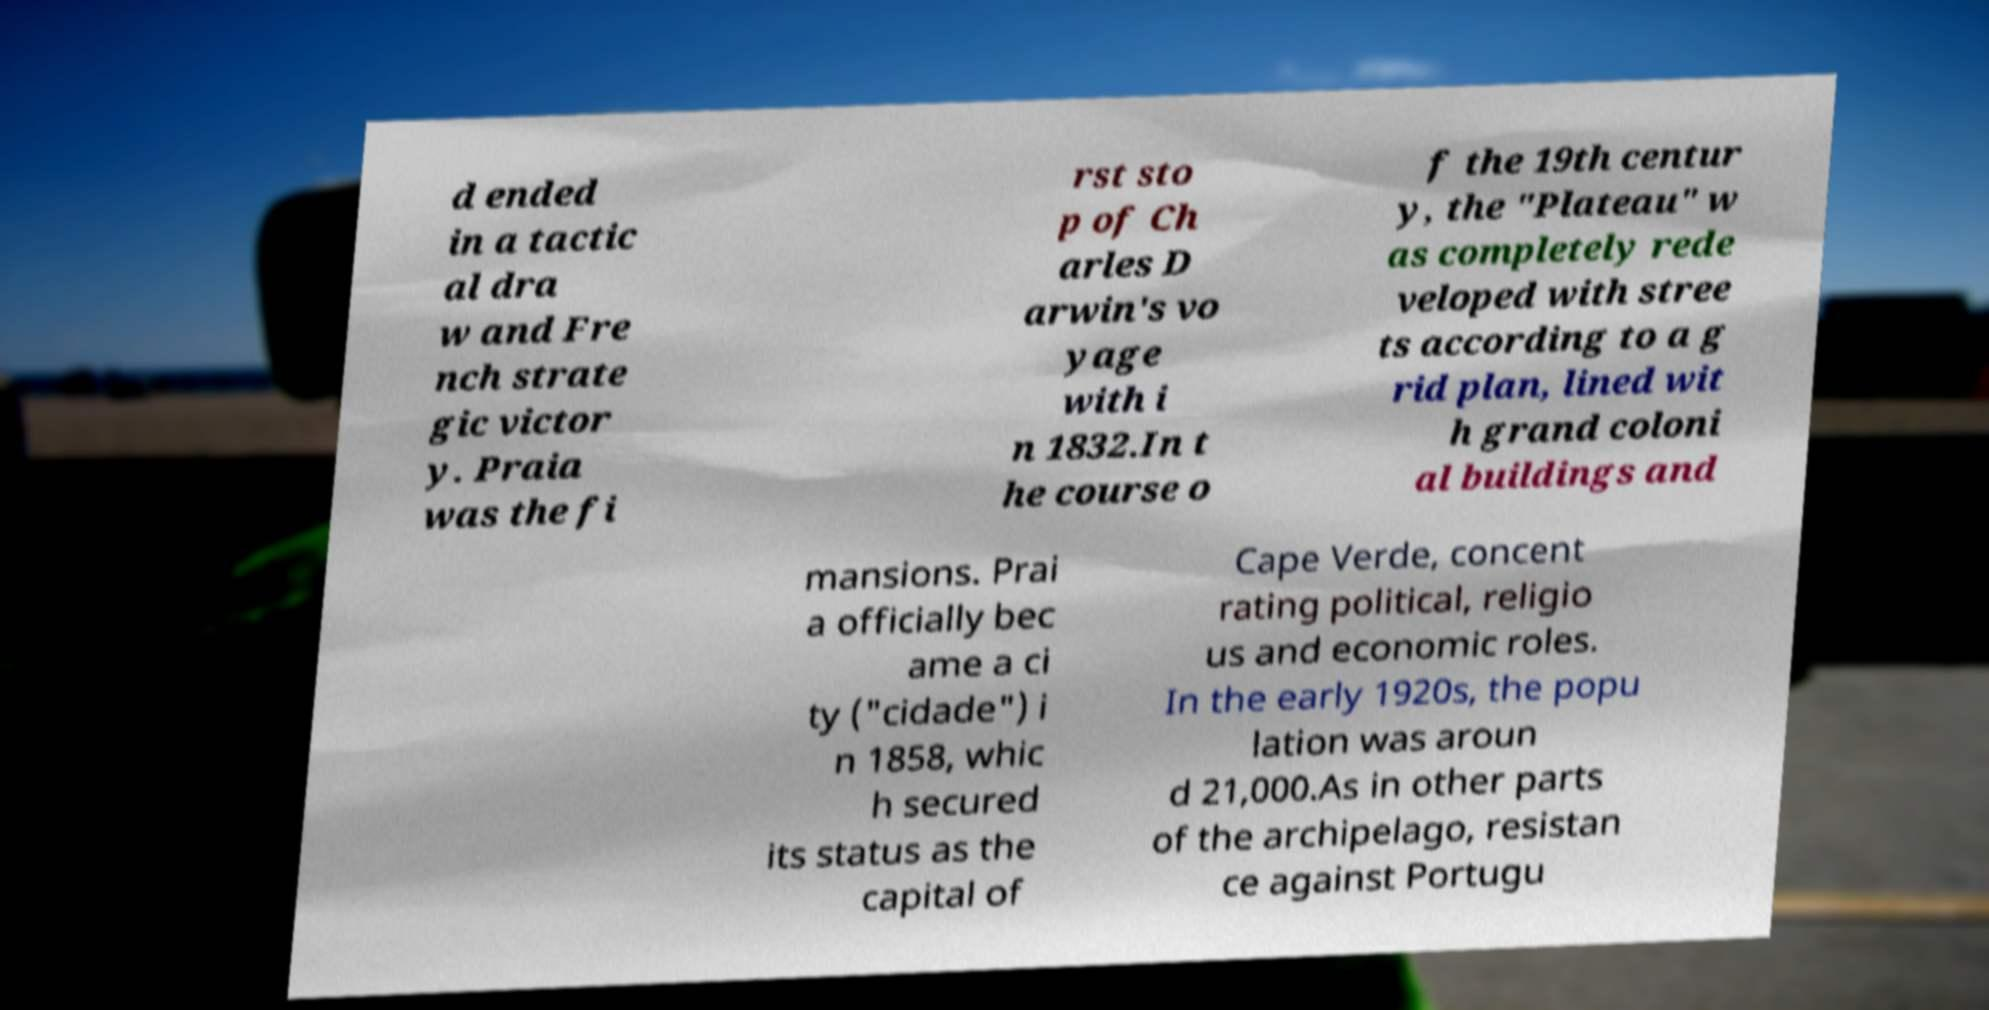Can you accurately transcribe the text from the provided image for me? d ended in a tactic al dra w and Fre nch strate gic victor y. Praia was the fi rst sto p of Ch arles D arwin's vo yage with i n 1832.In t he course o f the 19th centur y, the "Plateau" w as completely rede veloped with stree ts according to a g rid plan, lined wit h grand coloni al buildings and mansions. Prai a officially bec ame a ci ty ("cidade") i n 1858, whic h secured its status as the capital of Cape Verde, concent rating political, religio us and economic roles. In the early 1920s, the popu lation was aroun d 21,000.As in other parts of the archipelago, resistan ce against Portugu 